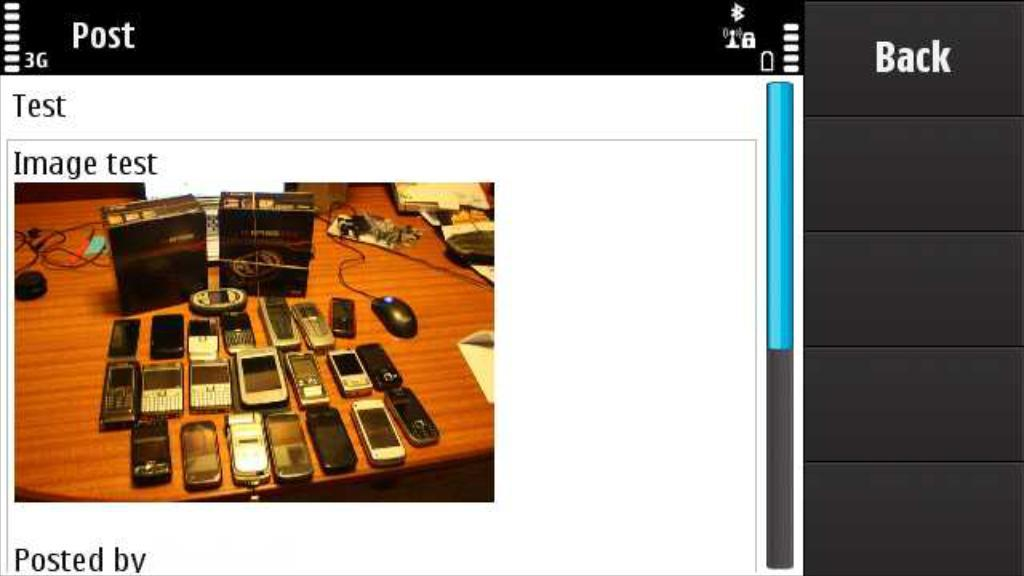Provide a one-sentence caption for the provided image. A screen has an image test and shows several cell phones. 